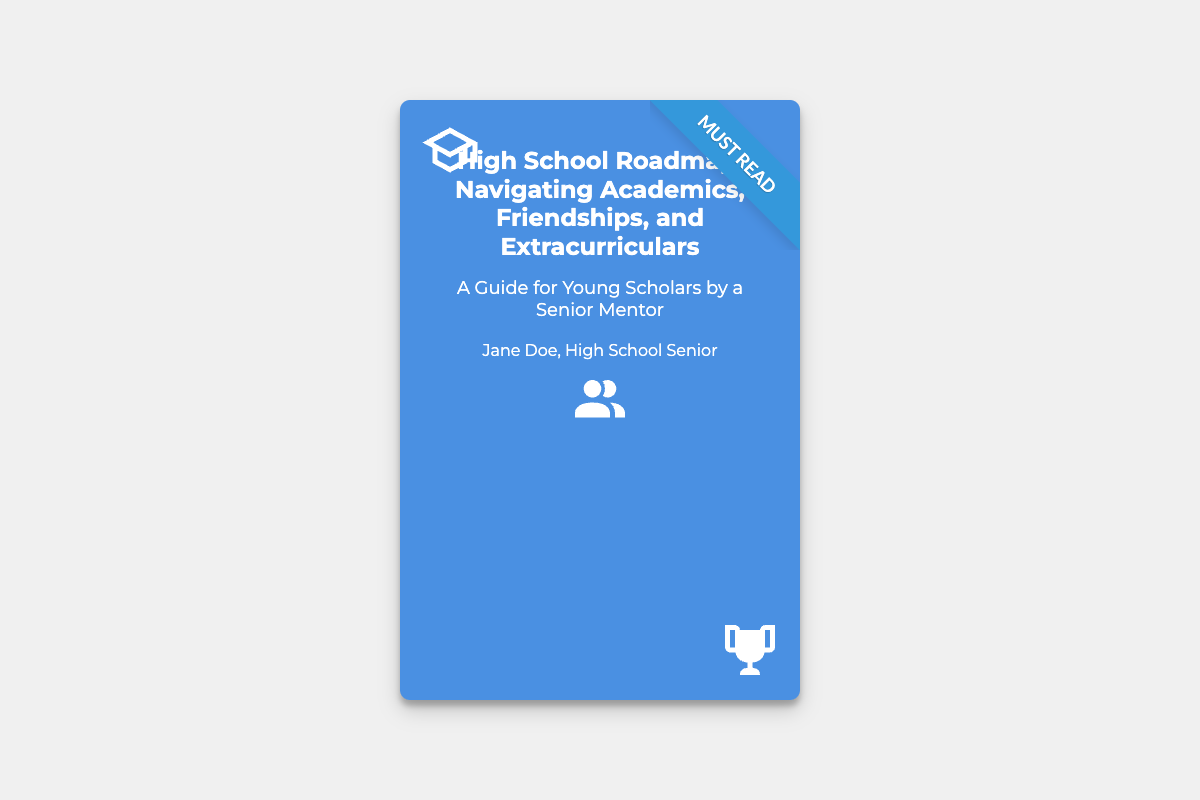What is the title of the book? The title of the book is clearly displayed at the top of the cover.
Answer: High School Roadmap: Navigating Academics, Friendships, and Extracurriculars Who is the author of the book? The author's name is mentioned at the bottom of the cover.
Answer: Jane Doe What is the subtitle of the book? The subtitle is presented below the main title on the cover.
Answer: A Guide for Young Scholars by a Senior Mentor What color is the book cover? The book cover is characterized by its prominent background color that gives it a distinct appearance.
Answer: Blue What type of icons are present on the cover? The cover features three specific icons that represent different themes related to the book's content.
Answer: Cap, friends, trophy What does the ribbon on the cover state? The ribbon at the top right corner contains an important phrase indicating the book's value.
Answer: Must Read How many icons are on the cover? The document contains a specific number of icons that visually enhance the cover's theme.
Answer: Three What is the main focus of the book? The main focus of the book is suggested through its title, which mentions key areas of high school life.
Answer: Academics, Friendships, Extracurriculars In what format is the book written? The document's format indicates that this is a guide aimed at a specific audience.
Answer: Guide 